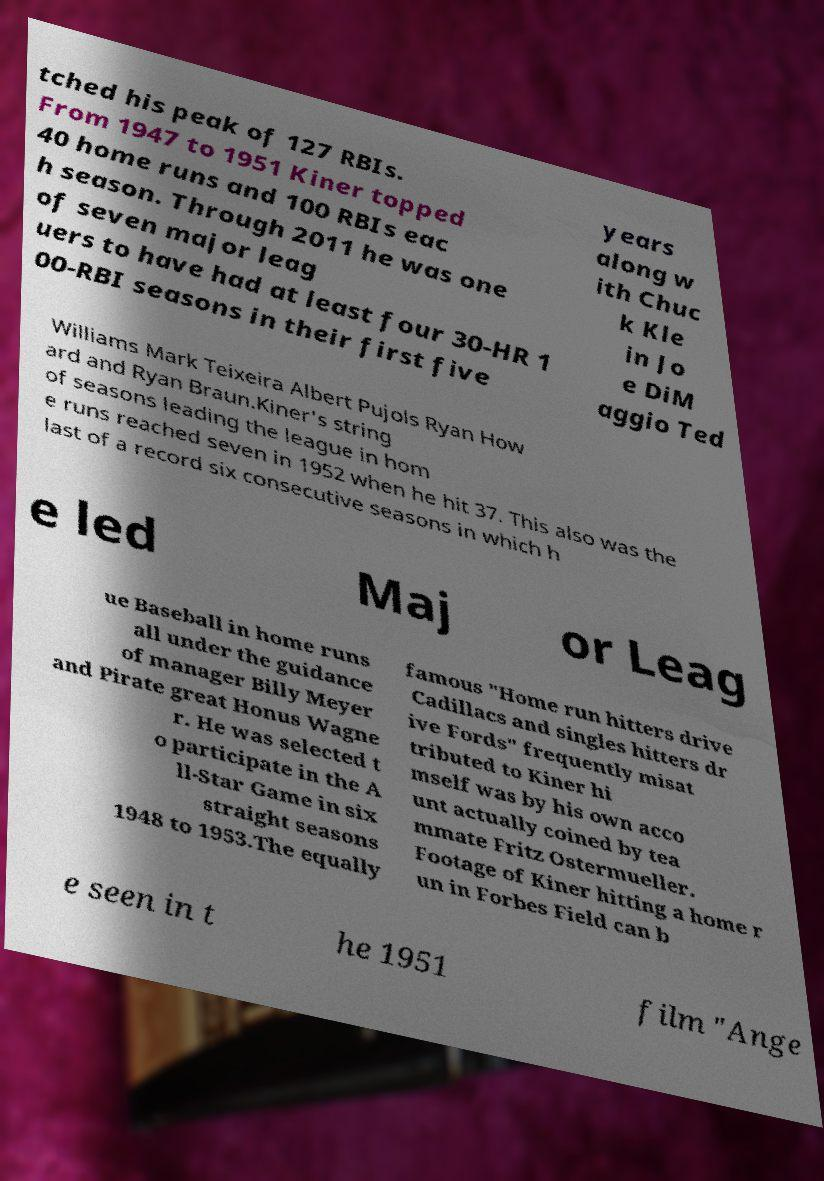Can you accurately transcribe the text from the provided image for me? tched his peak of 127 RBIs. From 1947 to 1951 Kiner topped 40 home runs and 100 RBIs eac h season. Through 2011 he was one of seven major leag uers to have had at least four 30-HR 1 00-RBI seasons in their first five years along w ith Chuc k Kle in Jo e DiM aggio Ted Williams Mark Teixeira Albert Pujols Ryan How ard and Ryan Braun.Kiner's string of seasons leading the league in hom e runs reached seven in 1952 when he hit 37. This also was the last of a record six consecutive seasons in which h e led Maj or Leag ue Baseball in home runs all under the guidance of manager Billy Meyer and Pirate great Honus Wagne r. He was selected t o participate in the A ll-Star Game in six straight seasons 1948 to 1953.The equally famous "Home run hitters drive Cadillacs and singles hitters dr ive Fords" frequently misat tributed to Kiner hi mself was by his own acco unt actually coined by tea mmate Fritz Ostermueller. Footage of Kiner hitting a home r un in Forbes Field can b e seen in t he 1951 film "Ange 